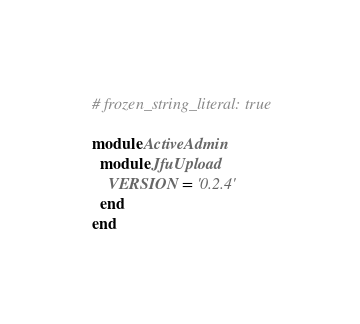<code> <loc_0><loc_0><loc_500><loc_500><_Ruby_># frozen_string_literal: true

module ActiveAdmin
  module JfuUpload
    VERSION = '0.2.4'
  end
end
</code> 